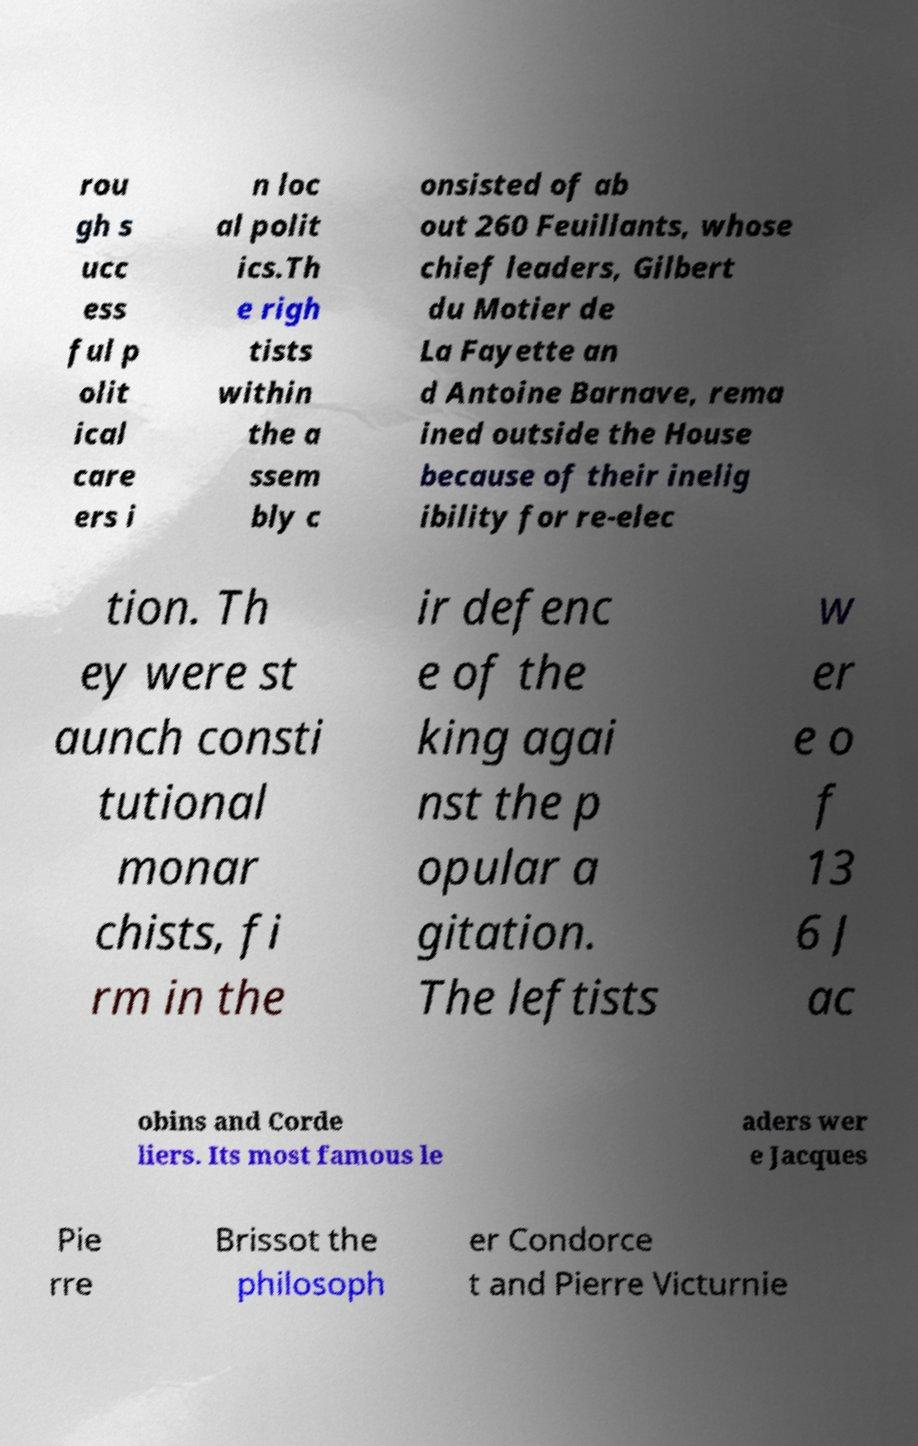What messages or text are displayed in this image? I need them in a readable, typed format. rou gh s ucc ess ful p olit ical care ers i n loc al polit ics.Th e righ tists within the a ssem bly c onsisted of ab out 260 Feuillants, whose chief leaders, Gilbert du Motier de La Fayette an d Antoine Barnave, rema ined outside the House because of their inelig ibility for re-elec tion. Th ey were st aunch consti tutional monar chists, fi rm in the ir defenc e of the king agai nst the p opular a gitation. The leftists w er e o f 13 6 J ac obins and Corde liers. Its most famous le aders wer e Jacques Pie rre Brissot the philosoph er Condorce t and Pierre Victurnie 